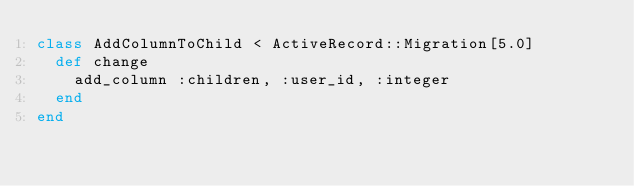<code> <loc_0><loc_0><loc_500><loc_500><_Ruby_>class AddColumnToChild < ActiveRecord::Migration[5.0]
  def change
    add_column :children, :user_id, :integer
  end
end
</code> 